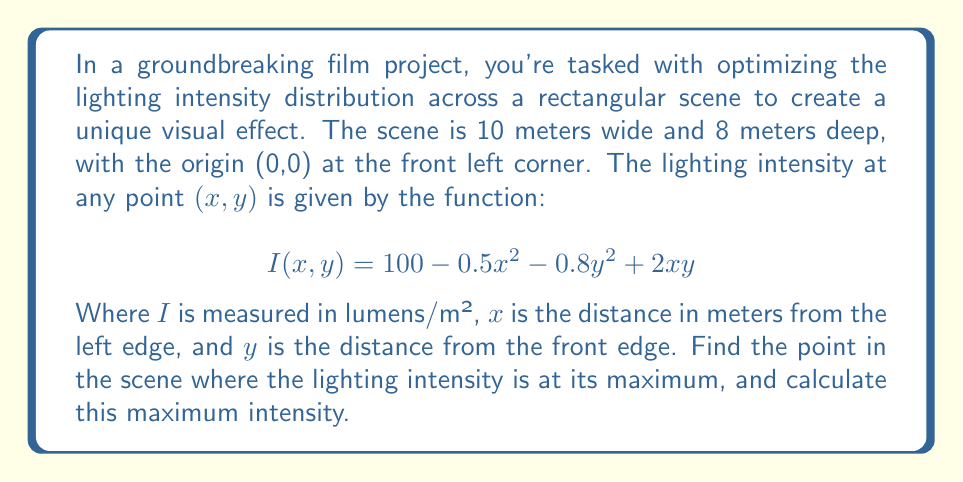Show me your answer to this math problem. To solve this problem, we'll use multivariable calculus to find the maximum of the function I(x,y) within the given domain.

1. First, we need to find the critical points by calculating the partial derivatives and setting them to zero:

   $$\frac{\partial I}{\partial x} = -x + 2y$$
   $$\frac{\partial I}{\partial y} = -1.6y + 2x$$

2. Set both partial derivatives to zero:
   $$-x + 2y = 0$$
   $$-1.6y + 2x = 0$$

3. Solve this system of equations:
   From the first equation: $x = 2y$
   Substitute into the second equation:
   $$-1.6y + 2(2y) = 0$$
   $$-1.6y + 4y = 0$$
   $$2.4y = 0$$
   $$y = 0$$

   If $y = 0$, then $x = 2y = 0$

4. The critical point is (0,0), but we also need to check the boundaries of our domain:
   x: 0 to 10
   y: 0 to 8

5. Evaluate I(x,y) at the critical point and the corners of the domain:
   I(0,0) = 100
   I(10,0) = 50
   I(0,8) = 48.8
   I(10,8) = 35.6

6. The maximum value occurs at (0,0), which is within our domain.

7. To confirm this is a maximum, we can check the second partial derivatives:
   $$\frac{\partial^2 I}{\partial x^2} = -1$$
   $$\frac{\partial^2 I}{\partial y^2} = -1.6$$
   $$\frac{\partial^2 I}{\partial x\partial y} = 2$$

   The Hessian matrix at (0,0) is:
   $$H = \begin{bmatrix} -1 & 2 \\ 2 & -1.6 \end{bmatrix}$$

   The determinant of H is positive and $\frac{\partial^2 I}{\partial x^2}$ is negative, confirming a local maximum.
Answer: The lighting intensity is maximized at the point (0,0), which corresponds to the front left corner of the scene. The maximum intensity is 100 lumens/m². 